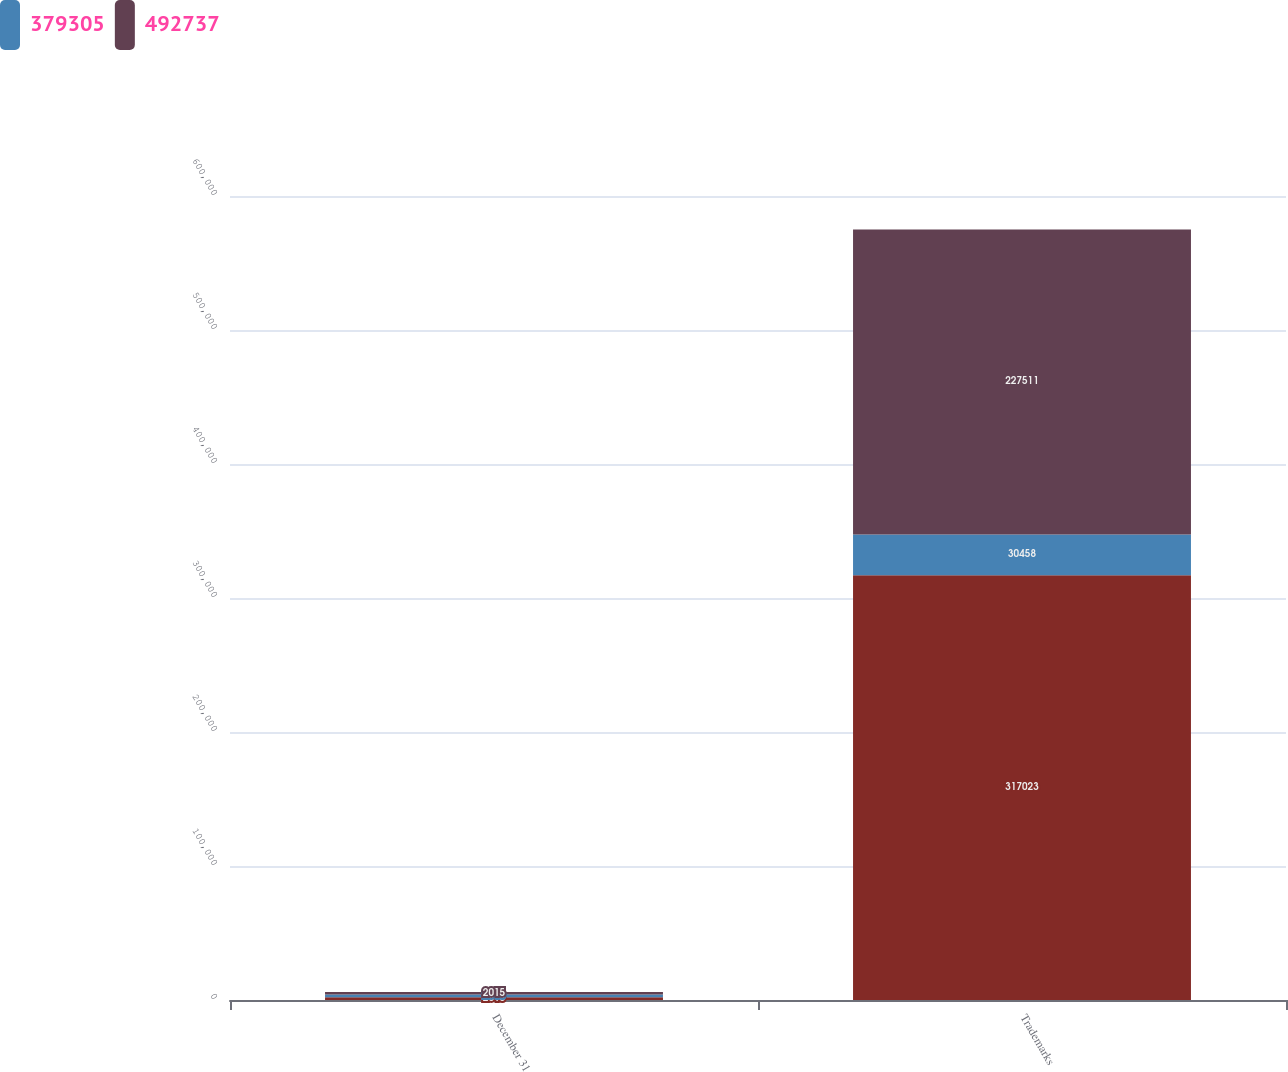Convert chart. <chart><loc_0><loc_0><loc_500><loc_500><stacked_bar_chart><ecel><fcel>December 31<fcel>Trademarks<nl><fcel>nan<fcel>2016<fcel>317023<nl><fcel>379305<fcel>2016<fcel>30458<nl><fcel>492737<fcel>2015<fcel>227511<nl></chart> 